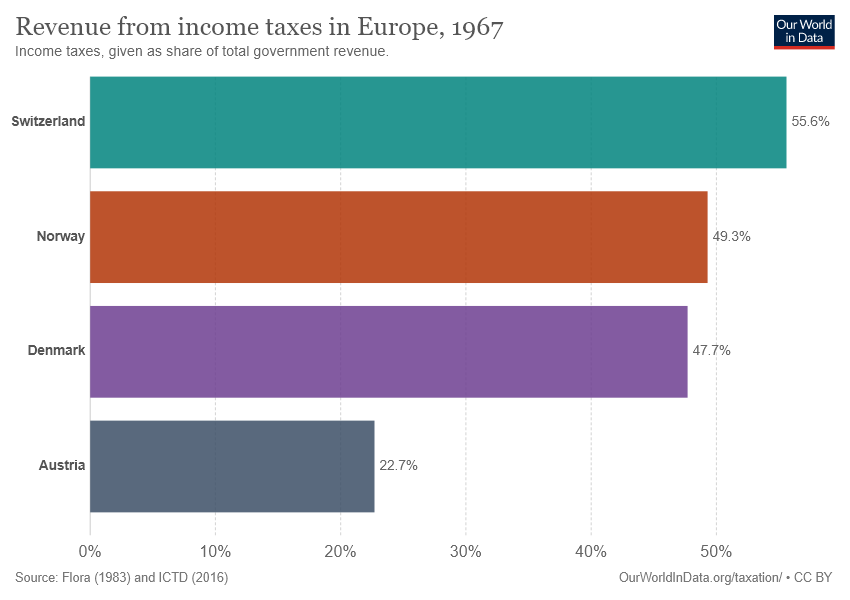Give some essential details in this illustration. There are four color bars used in the graph. The average of Norway and Denmark is not equal to Austria. 